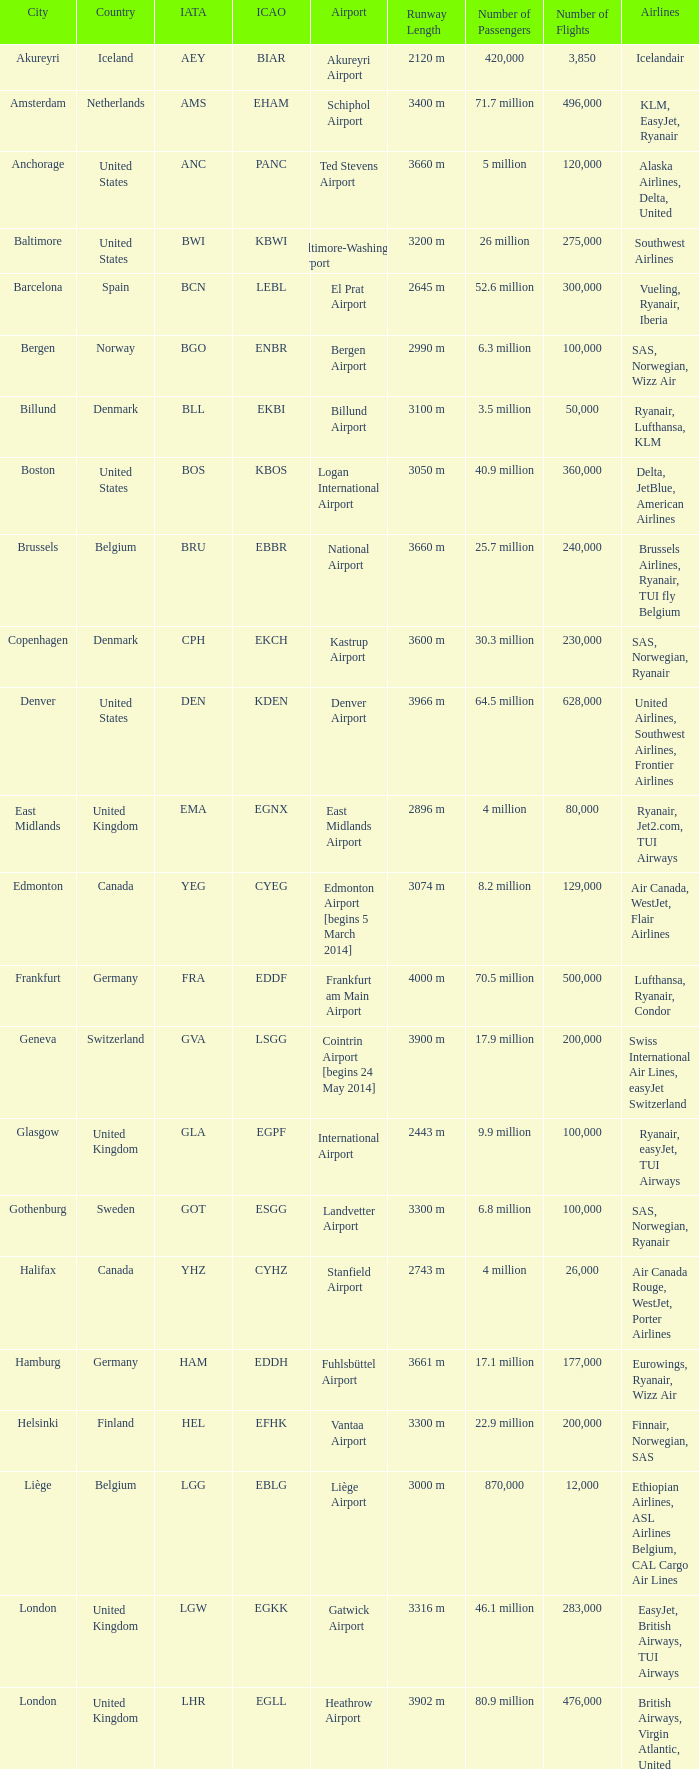What is the IATA OF Akureyri? AEY. Give me the full table as a dictionary. {'header': ['City', 'Country', 'IATA', 'ICAO', 'Airport', 'Runway Length', 'Number of Passengers', 'Number of Flights', 'Airlines'], 'rows': [['Akureyri', 'Iceland', 'AEY', 'BIAR', 'Akureyri Airport', '2120 m', '420,000', '3,850', 'Icelandair'], ['Amsterdam', 'Netherlands', 'AMS', 'EHAM', 'Schiphol Airport', '3400 m', '71.7 million', '496,000', 'KLM, EasyJet, Ryanair'], ['Anchorage', 'United States', 'ANC', 'PANC', 'Ted Stevens Airport', '3660 m', '5 million', '120,000', 'Alaska Airlines, Delta, United'], ['Baltimore', 'United States', 'BWI', 'KBWI', 'Baltimore-Washington Airport', '3200 m', '26 million', '275,000', 'Southwest Airlines'], ['Barcelona', 'Spain', 'BCN', 'LEBL', 'El Prat Airport', '2645 m', '52.6 million', '300,000', 'Vueling, Ryanair, Iberia'], ['Bergen', 'Norway', 'BGO', 'ENBR', 'Bergen Airport', '2990 m', '6.3 million', '100,000', 'SAS, Norwegian, Wizz Air'], ['Billund', 'Denmark', 'BLL', 'EKBI', 'Billund Airport', '3100 m', '3.5 million', '50,000', 'Ryanair, Lufthansa, KLM'], ['Boston', 'United States', 'BOS', 'KBOS', 'Logan International Airport', '3050 m', '40.9 million', '360,000', 'Delta, JetBlue, American Airlines'], ['Brussels', 'Belgium', 'BRU', 'EBBR', 'National Airport', '3660 m', '25.7 million', '240,000', 'Brussels Airlines, Ryanair, TUI fly Belgium'], ['Copenhagen', 'Denmark', 'CPH', 'EKCH', 'Kastrup Airport', '3600 m', '30.3 million', '230,000', 'SAS, Norwegian, Ryanair'], ['Denver', 'United States', 'DEN', 'KDEN', 'Denver Airport', '3966 m', '64.5 million', '628,000', 'United Airlines, Southwest Airlines, Frontier Airlines'], ['East Midlands', 'United Kingdom', 'EMA', 'EGNX', 'East Midlands Airport', '2896 m', '4 million', '80,000', 'Ryanair, Jet2.com, TUI Airways'], ['Edmonton', 'Canada', 'YEG', 'CYEG', 'Edmonton Airport [begins 5 March 2014]', '3074 m', '8.2 million', '129,000', 'Air Canada, WestJet, Flair Airlines'], ['Frankfurt', 'Germany', 'FRA', 'EDDF', 'Frankfurt am Main Airport', '4000 m', '70.5 million', '500,000', 'Lufthansa, Ryanair, Condor'], ['Geneva', 'Switzerland', 'GVA', 'LSGG', 'Cointrin Airport [begins 24 May 2014]', '3900 m', '17.9 million', '200,000', 'Swiss International Air Lines, easyJet Switzerland'], ['Glasgow', 'United Kingdom', 'GLA', 'EGPF', 'International Airport', '2443 m', '9.9 million', '100,000', 'Ryanair, easyJet, TUI Airways'], ['Gothenburg', 'Sweden', 'GOT', 'ESGG', 'Landvetter Airport', '3300 m', '6.8 million', '100,000', 'SAS, Norwegian, Ryanair'], ['Halifax', 'Canada', 'YHZ', 'CYHZ', 'Stanfield Airport', '2743 m', '4 million', '26,000', 'Air Canada Rouge, WestJet, Porter Airlines'], ['Hamburg', 'Germany', 'HAM', 'EDDH', 'Fuhlsbüttel Airport', '3661 m', '17.1 million', '177,000', 'Eurowings, Ryanair, Wizz Air'], ['Helsinki', 'Finland', 'HEL', 'EFHK', 'Vantaa Airport', '3300 m', '22.9 million', '200,000', 'Finnair, Norwegian, SAS'], ['Liège', 'Belgium', 'LGG', 'EBLG', 'Liège Airport', '3000 m', '870,000', '12,000', 'Ethiopian Airlines, ASL Airlines Belgium, CAL Cargo Air Lines'], ['London', 'United Kingdom', 'LGW', 'EGKK', 'Gatwick Airport', '3316 m', '46.1 million', '283,000', 'EasyJet, British Airways, TUI Airways'], ['London', 'United Kingdom', 'LHR', 'EGLL', 'Heathrow Airport', '3902 m', '80.9 million', '476,000', 'British Airways, Virgin Atlantic, United Airlines'], ['Luxembourg City', 'Luxembourg', 'LUX', 'ELLX', 'Findel Airport', '4000 m', '4.4 million', '75,000', 'Luxair, Ryanair, TUI fly Belgium'], ['Madrid', 'Spain', 'MAD', 'LEMD', 'Barajas Airport', '4100 m', '61.7 million', '400,000', 'Iberia, Ryanair, Air Europa'], ['Manchester', 'United Kingdom', 'MAN', 'EGCC', 'Ringway Airport', '3048 m', '29.5 million', '210,000', 'Ryanair, Jet2.com, easyJet'], ['Milan', 'Italy', 'MXP', 'LIMC', 'Malpensa Airport', '3900 m', '28.7 million', '233,000', 'Alitalia, EasyJet, Ryanair'], ['Minneapolis', 'United States', 'MSP', 'KMSP', 'Minneapolis-St Paul Airport', '3658 m', '38 million', '400,000', 'Delta, Sun Country Airlines, Spirit Airlines'], ['Munich', 'Germany', 'MUC', 'EDDM', 'Franz Josef Strauss Airport', '4000 m', '47.9 million', '400,000', 'Lufthansa, Eurowings, easyJet'], ['New York City', 'United States', 'JFK', 'KJFK', 'John F. Kennedy Airport', '4426 m', '59.3 million', '457,000', 'Delta, JetBlue, American Airlines'], ['Newark', 'United States', 'EWR', 'KEWR', 'Liberty Airport', '3355 m', '46.1 million', '400,000', 'United Airlines, American Airlines, Air Canada'], ['Orlando', 'United States', 'MCO', 'KMCO', 'Orlando Airport', '3658 m', '50.6 million', '450,000', 'Southwest Airlines, JetBlue, Delta'], ['Orlando', 'United States', 'SFB', 'KSFB', 'Sanford Airport', '3000 m', '3.3 million', '10,000', 'Allegiant Air, Surinam Airways, Sun Country Airlines'], ['Oslo', 'Norway', 'OSL', 'ENGM', 'Gardermoen Airport', '3600 m', '28.5 million', '230,000', 'SAS, Norwegian, Wizz Air'], ['Paris', 'France', 'CDG', 'LFPG', 'Charles de Gaulle Airport', '4100 m', '76.1 million', '500,000', 'Air France, Delta, Norwegian'], ['Reykjavík', 'Iceland', 'KEF', 'BIKF', 'Keflavik Airport', '3060 m', '9.8 million', '70,000', 'Icelandair, easyJet, Wizz Air'], ['Saint Petersburg', 'Russia', 'LED', 'ULLI', 'Pulkovo Airport', '2981 m', '20 million', '200,000', 'Aeroflot, Pobeda, Rossiya Airlines'], ['San Francisco', 'United States', 'SFO', 'KSFO', 'San Francisco Airport', '3612 m', '57.7 million', '470,000', 'United Airlines, Delta, Southwest Airlines'], ['Seattle', 'United States', 'SEA', 'KSEA', 'Seattle–Tacoma Airport', '3400 m', '51.8 million', '426,000', 'Alaska Airlines, Delta, Spirit Airlines'], ['Stavanger', 'Norway', 'SVG', 'ENZV', 'Sola Airport', '2940 m', '4.4 million', '60,000', 'Norwegian, Wizz Air, KLM'], ['Stockholm', 'Sweden', 'ARN', 'ESSA', 'Arlanda Airport', '3300 m', '27.5 million', '200,000', 'SAS, Norwegian, Ryanair'], ['Toronto', 'Canada', 'YYZ', 'CYYZ', 'Pearson Airport', '3628 m', '49.5 million', '465,000', 'Air Canada, WestJet, American Airlines'], ['Trondheim', 'Norway', 'TRD', 'ENVA', 'Trondheim Airport', '3120 m', '4.4 million', '60,000', 'SAS, Norwegian, Wizz Air'], ['Vancouver', 'Canada', 'YVR', 'CYVR', 'Vancouver Airport [begins 13 May 2014]', '3534 m', '25.9 million', '325,000', 'Air Canada, WestJet, Delta'], ['Washington, D.C.', 'United States', 'IAD', 'KIAD', 'Dulles Airport', '3707 m', '23.9 million', '215,000', 'United Airlines, Virgin Atlantic, an Airlines'], ['Zurich', 'Switzerland', 'ZRH', 'LSZH', 'Kloten Airport', '3700 m', '31 million', '250,000', 'Swiss International Air Lines, Edelweiss Air, Austrian Airlines']]} 